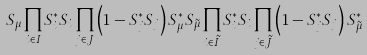Convert formula to latex. <formula><loc_0><loc_0><loc_500><loc_500>S _ { \mu } \prod _ { i \in I } S _ { i } ^ { * } S _ { i } \prod _ { j \in J } \left ( 1 - S _ { j } ^ { * } S _ { j } \right ) S _ { \mu } ^ { * } S _ { \tilde { \mu } } \prod _ { i \in \tilde { I } } S _ { i } ^ { * } S _ { i } \prod _ { j \in \tilde { J } } \left ( 1 - S _ { j } ^ { * } S _ { j } \right ) S _ { \tilde { \mu } } ^ { * }</formula> 